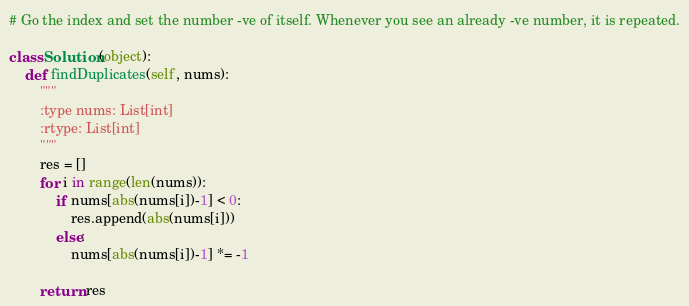<code> <loc_0><loc_0><loc_500><loc_500><_Python_># Go the index and set the number -ve of itself. Whenever you see an already -ve number, it is repeated.

class Solution(object):
    def findDuplicates(self, nums):
        """
        :type nums: List[int]
        :rtype: List[int]
        """
        res = []
        for i in range(len(nums)):
            if nums[abs(nums[i])-1] < 0:
                res.append(abs(nums[i]))
            else:
                nums[abs(nums[i])-1] *= -1
                
        return res</code> 